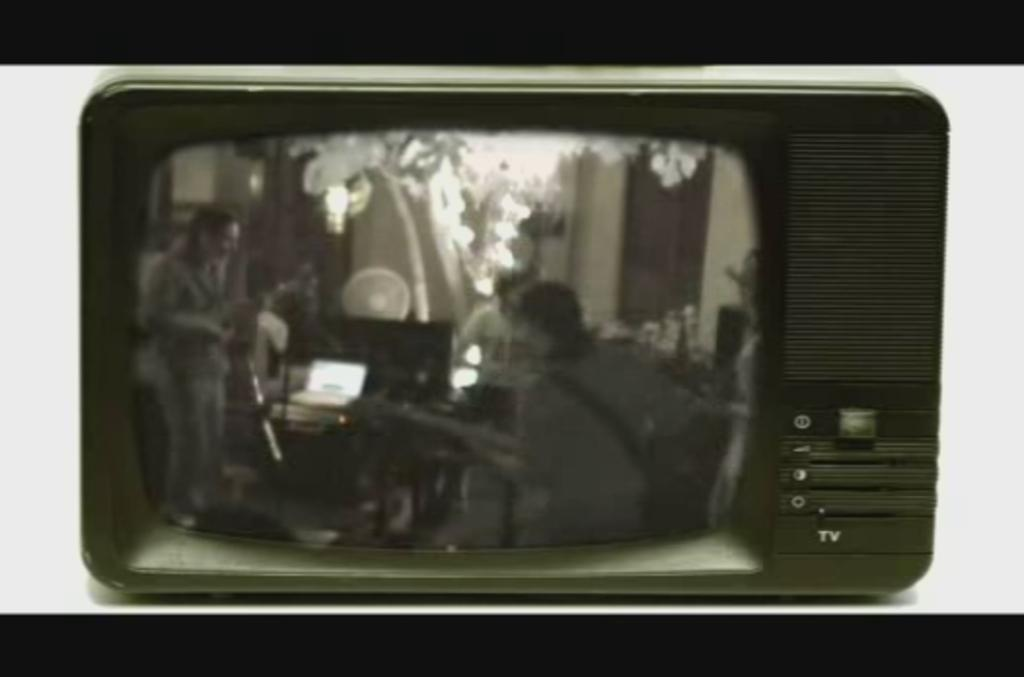What is the main object in the center of the image? There is a television in the center of the image. What color is the background of the television screen? The television has a white background. What colors are present at the top and bottom of the image? The top and bottom of the image have black color. Where is the throne located in the image? There is no throne present in the image. What type of powder can be seen on the television screen? There is no powder visible on the television screen in the image. 